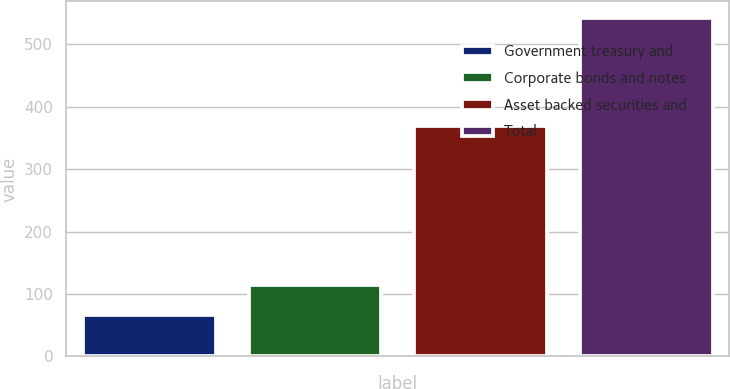Convert chart. <chart><loc_0><loc_0><loc_500><loc_500><bar_chart><fcel>Government treasury and<fcel>Corporate bonds and notes<fcel>Asset backed securities and<fcel>Total<nl><fcel>67<fcel>114.48<fcel>369.7<fcel>541.8<nl></chart> 